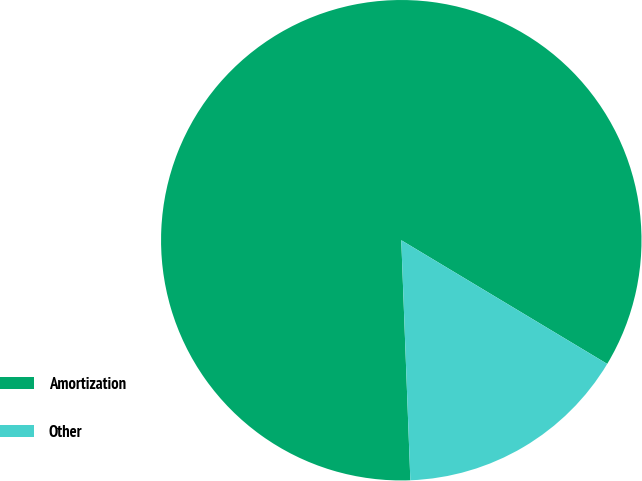<chart> <loc_0><loc_0><loc_500><loc_500><pie_chart><fcel>Amortization<fcel>Other<nl><fcel>84.21%<fcel>15.79%<nl></chart> 